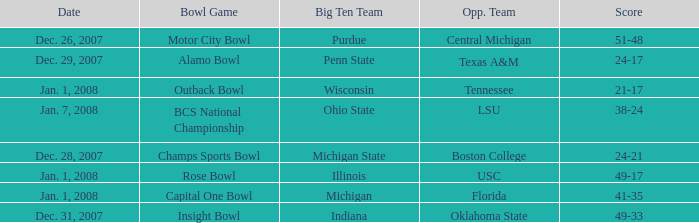What was the score of the Insight Bowl? 49-33. 